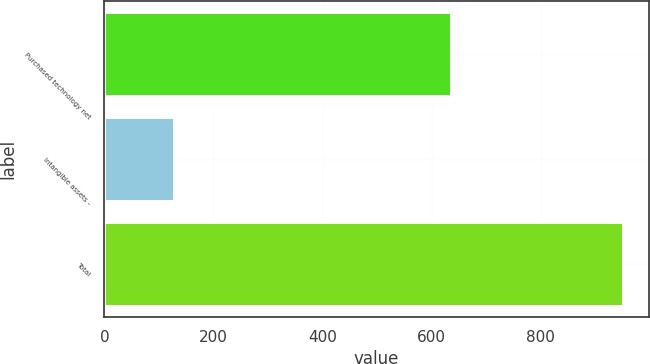Convert chart. <chart><loc_0><loc_0><loc_500><loc_500><bar_chart><fcel>Purchased technology net<fcel>Intangible assets -<fcel>Total<nl><fcel>636<fcel>127<fcel>951<nl></chart> 